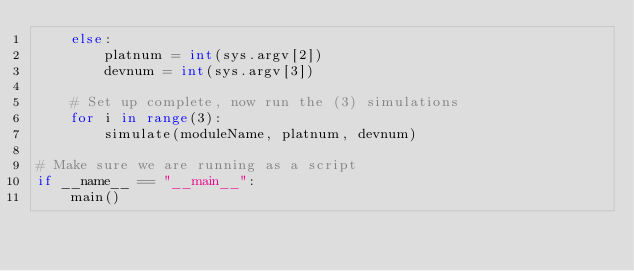Convert code to text. <code><loc_0><loc_0><loc_500><loc_500><_Python_>    else:
        platnum = int(sys.argv[2])
        devnum = int(sys.argv[3])

    # Set up complete, now run the (3) simulations
    for i in range(3):
        simulate(moduleName, platnum, devnum)

# Make sure we are running as a script
if __name__ == "__main__": 
    main()

</code> 